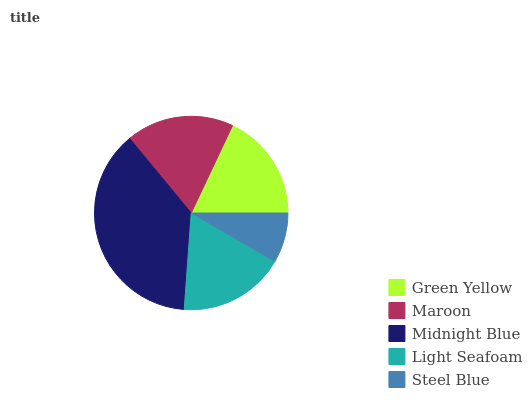Is Steel Blue the minimum?
Answer yes or no. Yes. Is Midnight Blue the maximum?
Answer yes or no. Yes. Is Maroon the minimum?
Answer yes or no. No. Is Maroon the maximum?
Answer yes or no. No. Is Maroon greater than Green Yellow?
Answer yes or no. Yes. Is Green Yellow less than Maroon?
Answer yes or no. Yes. Is Green Yellow greater than Maroon?
Answer yes or no. No. Is Maroon less than Green Yellow?
Answer yes or no. No. Is Green Yellow the high median?
Answer yes or no. Yes. Is Green Yellow the low median?
Answer yes or no. Yes. Is Steel Blue the high median?
Answer yes or no. No. Is Steel Blue the low median?
Answer yes or no. No. 